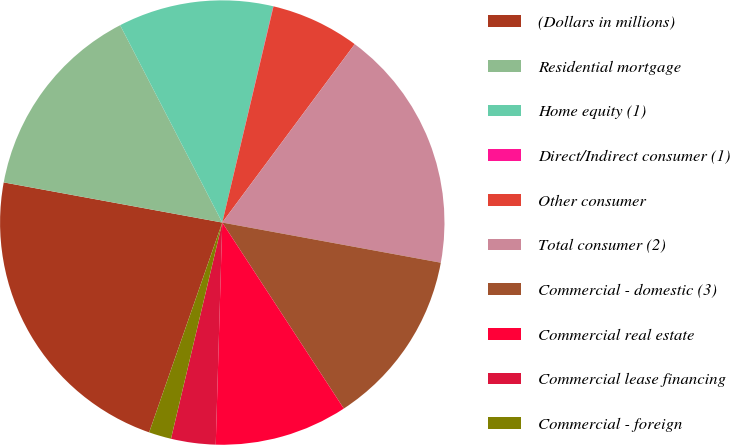<chart> <loc_0><loc_0><loc_500><loc_500><pie_chart><fcel>(Dollars in millions)<fcel>Residential mortgage<fcel>Home equity (1)<fcel>Direct/Indirect consumer (1)<fcel>Other consumer<fcel>Total consumer (2)<fcel>Commercial - domestic (3)<fcel>Commercial real estate<fcel>Commercial lease financing<fcel>Commercial - foreign<nl><fcel>22.56%<fcel>14.51%<fcel>11.29%<fcel>0.02%<fcel>6.46%<fcel>17.73%<fcel>12.9%<fcel>9.68%<fcel>3.24%<fcel>1.63%<nl></chart> 